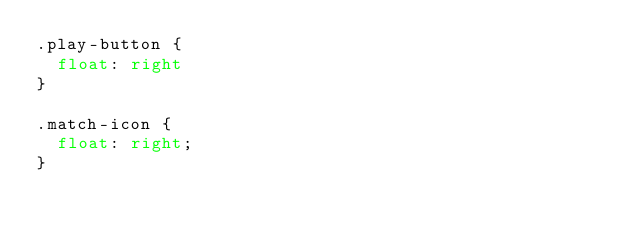<code> <loc_0><loc_0><loc_500><loc_500><_CSS_>.play-button {
  float: right
}

.match-icon {
  float: right;
}
</code> 